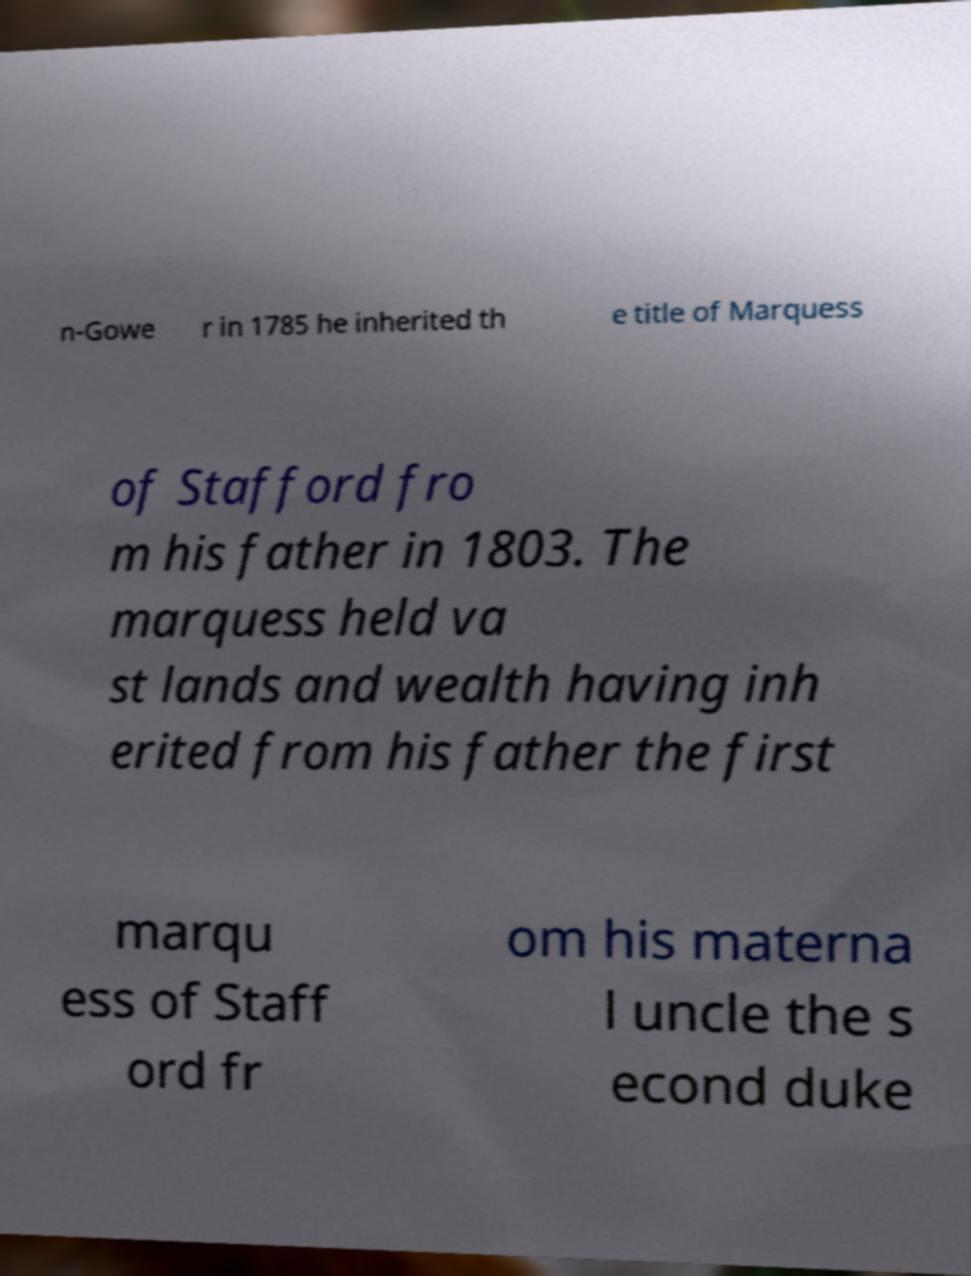Please identify and transcribe the text found in this image. n-Gowe r in 1785 he inherited th e title of Marquess of Stafford fro m his father in 1803. The marquess held va st lands and wealth having inh erited from his father the first marqu ess of Staff ord fr om his materna l uncle the s econd duke 